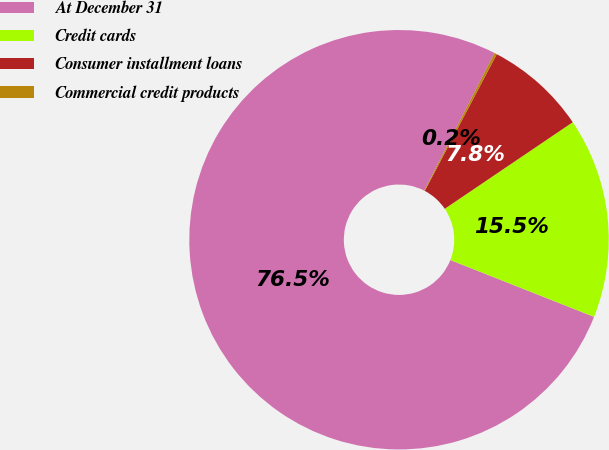Convert chart to OTSL. <chart><loc_0><loc_0><loc_500><loc_500><pie_chart><fcel>At December 31<fcel>Credit cards<fcel>Consumer installment loans<fcel>Commercial credit products<nl><fcel>76.53%<fcel>15.46%<fcel>7.82%<fcel>0.19%<nl></chart> 